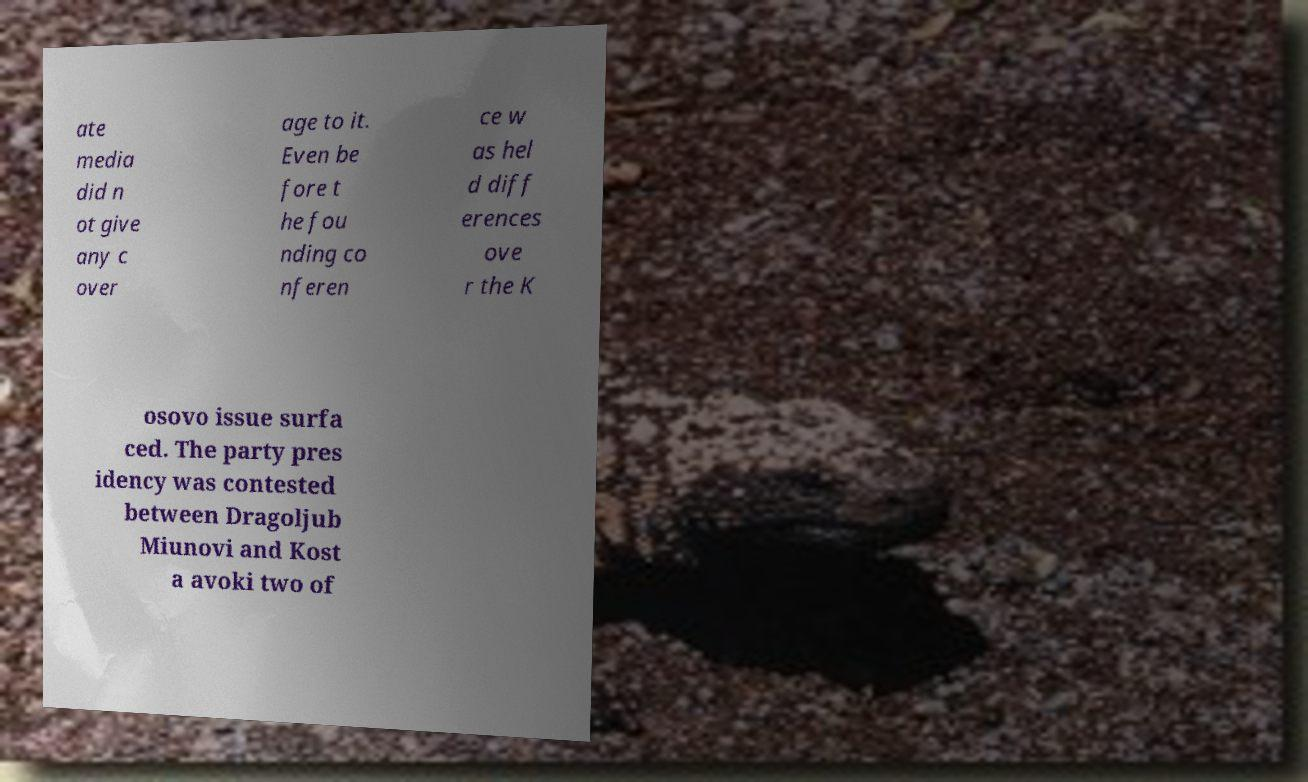I need the written content from this picture converted into text. Can you do that? ate media did n ot give any c over age to it. Even be fore t he fou nding co nferen ce w as hel d diff erences ove r the K osovo issue surfa ced. The party pres idency was contested between Dragoljub Miunovi and Kost a avoki two of 